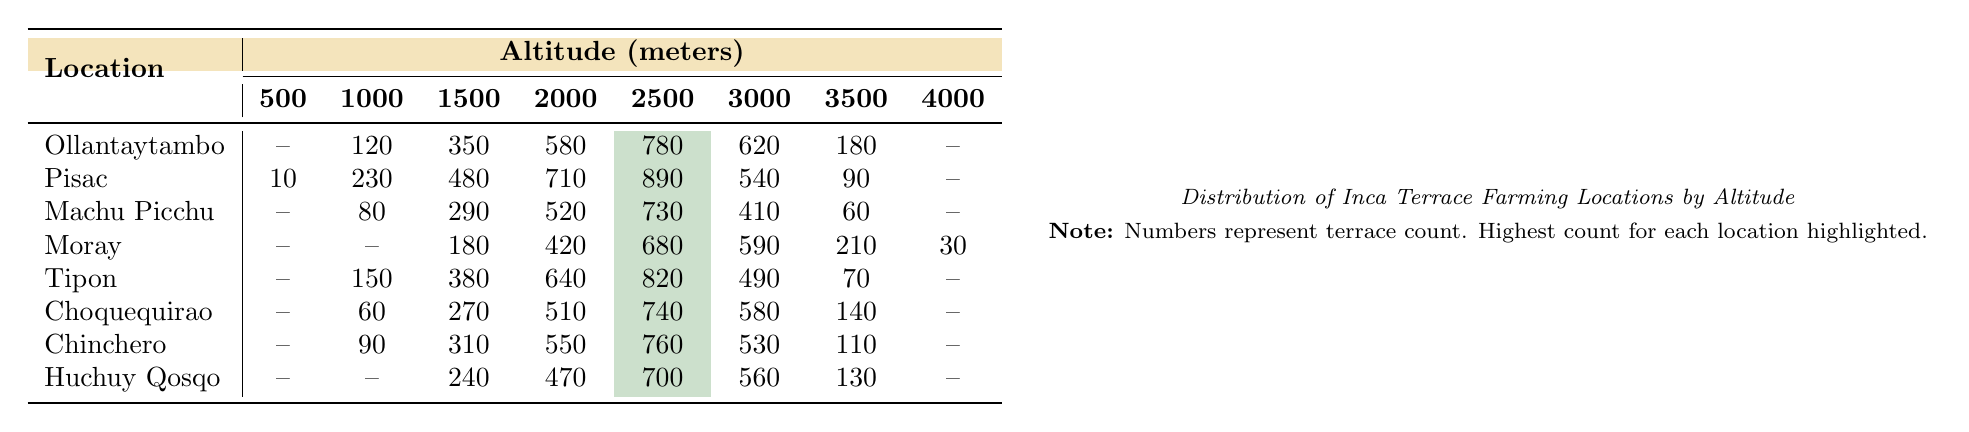What is the terrace count at 2500 meters for Pisac? The table shows that the terrace count at 2500 meters for Pisac is 890.
Answer: 890 Which location has the highest terrace count at 2000 meters? By examining the table, Ollantaytambo has a terrace count of 580, Pisac has 710, Machu Picchu has 520, Moray has 420, Tipon has 640, Choquequirao has 510, Chinchero has 550, and Huchuy Qosqo has 470. The highest count is for Pisac at 710.
Answer: Pisac What is the terrace count difference between 1500 meters and 3000 meters for Moray? At 1500 meters, Moray has a terrace count of 180, and at 3000 meters, it has 590. The difference is calculated as 590 - 180 = 410.
Answer: 410 Which two locations have a terrace count of zero at 500 meters? The locations that have a terrace count of zero at 500 meters are Ollantaytambo and Moray.
Answer: Ollantaytambo and Moray What is the average terrace count across all locations at 1000 meters? The terrace counts at 1000 meters are 120 (Ollantaytambo), 230 (Pisac), 80 (Machu Picchu), 0 (Moray), 150 (Tipon), 60 (Choquequirao), 90 (Chinchero), and 0 (Huchuy Qosqo). The total is 730, and there are 8 locations, so the average is 730/8 = 91.25.
Answer: 91.25 Is there any location that has more than 600 terraces at 3000 meters? Checking the table, Pisac has 540, Machu Picchu has 410, Moray has 590, Tipon has 490, Choquequirao has 580, Chinchero has 530, and Huchuy Qosqo has 560. None of these values exceed 600.
Answer: No Which location shows a consistent decrease in terrace count from 2000 to 4000 meters? Looking at the terrace counts for each location at 2000, 3000, and 4000 meters, Moray decreases from 420 to 210, Tipon from 640 to 70, Choquequirao from 510 to 140, and Chinchero from 550 to 110, indicating that Moray is the only location that does not drop below 210 at 4000 meters.
Answer: No location shows consistent decrease; Tipon decreases more sharply Which altitude has the maximum terrace count across all locations? The highest terrace count found in the table is at 2500 meters with a maximum count of 890 from Pisac.
Answer: 890 at 2500 meters What is the terrace count sum for Huchuy Qosqo across all altitudes? Summing the terrace counts for Huchuy Qosqo, we find the counts are 0 (500m), 0 (1000m), 240 (1500m), 470 (2000m), 700 (2500m), 560 (3000m), 130 (3500m), 0 (4000m) which totals to 0 + 0 + 240 + 470 + 700 + 560 + 130 + 0 = 2100.
Answer: 2100 How many locations have more than 500 terraces at 2000 meters? At 2000 meters, the terrace counts are: Ollantaytambo (580), Pisac (710), Machu Picchu (520), Moray (420), Tipon (640), Choquequirao (510), Chinchero (550), and Huchuy Qosqo (470). The locations with more than 500 terraces are Ollantaytambo, Pisac, Machu Picchu, Tipon, Choquequirao, and Chinchero, totaling 6 locations.
Answer: 6 locations 